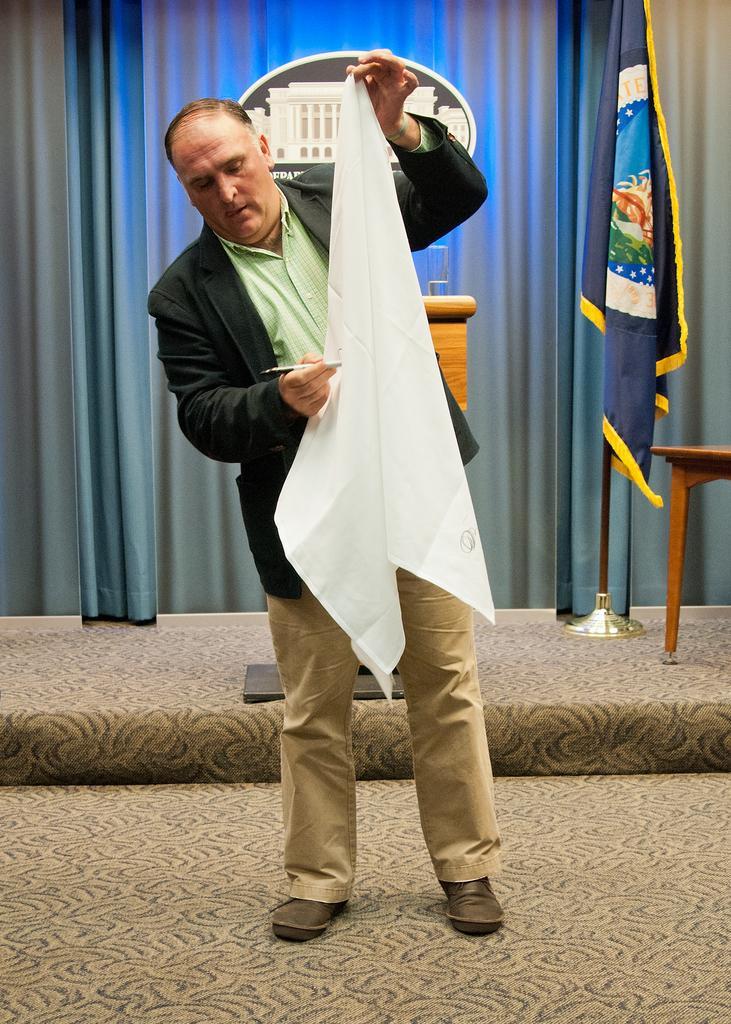Describe this image in one or two sentences. In this picture we can see an old man standing with a white cloth in one hand and a pen in another hand. 